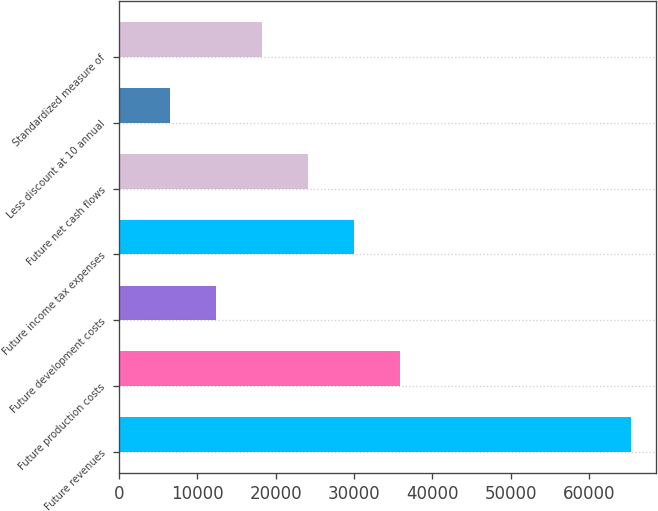<chart> <loc_0><loc_0><loc_500><loc_500><bar_chart><fcel>Future revenues<fcel>Future production costs<fcel>Future development costs<fcel>Future income tax expenses<fcel>Future net cash flows<fcel>Less discount at 10 annual<fcel>Standardized measure of<nl><fcel>65275<fcel>35898<fcel>12396.4<fcel>30022.6<fcel>24147.2<fcel>6521<fcel>18271.8<nl></chart> 